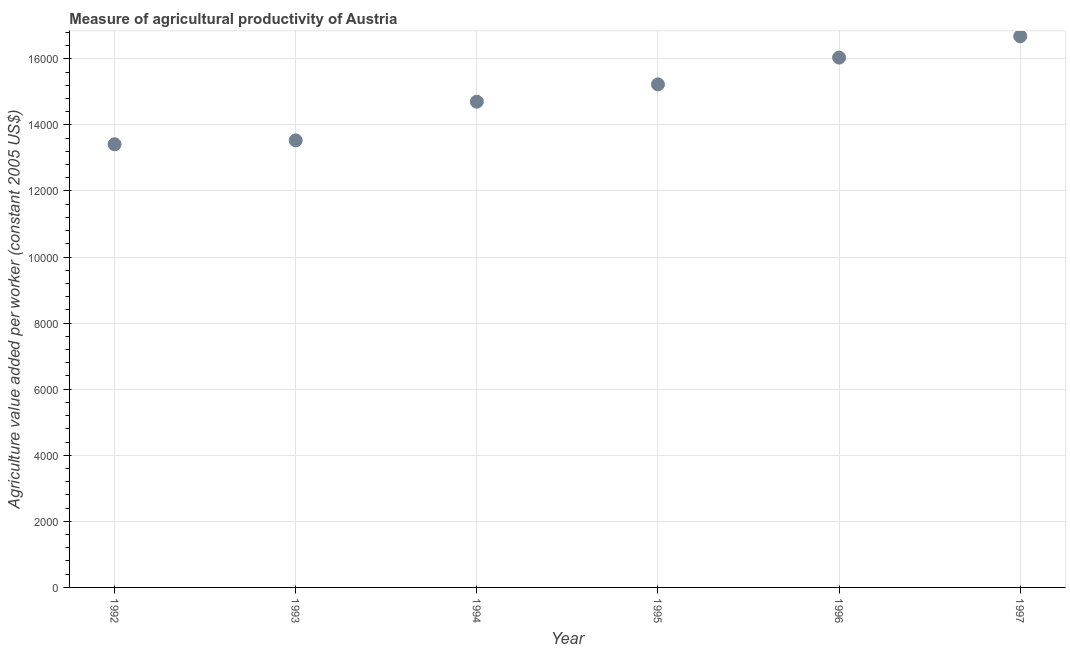What is the agriculture value added per worker in 1993?
Offer a terse response. 1.35e+04. Across all years, what is the maximum agriculture value added per worker?
Offer a terse response. 1.67e+04. Across all years, what is the minimum agriculture value added per worker?
Offer a very short reply. 1.34e+04. In which year was the agriculture value added per worker maximum?
Your answer should be compact. 1997. What is the sum of the agriculture value added per worker?
Your response must be concise. 8.96e+04. What is the difference between the agriculture value added per worker in 1992 and 1994?
Offer a very short reply. -1288.85. What is the average agriculture value added per worker per year?
Make the answer very short. 1.49e+04. What is the median agriculture value added per worker?
Give a very brief answer. 1.50e+04. Do a majority of the years between 1993 and 1994 (inclusive) have agriculture value added per worker greater than 11600 US$?
Your answer should be very brief. Yes. What is the ratio of the agriculture value added per worker in 1992 to that in 1997?
Provide a short and direct response. 0.8. Is the difference between the agriculture value added per worker in 1994 and 1996 greater than the difference between any two years?
Keep it short and to the point. No. What is the difference between the highest and the second highest agriculture value added per worker?
Offer a terse response. 646.43. What is the difference between the highest and the lowest agriculture value added per worker?
Offer a terse response. 3269.82. How many dotlines are there?
Keep it short and to the point. 1. Are the values on the major ticks of Y-axis written in scientific E-notation?
Your answer should be very brief. No. Does the graph contain any zero values?
Keep it short and to the point. No. Does the graph contain grids?
Ensure brevity in your answer.  Yes. What is the title of the graph?
Offer a terse response. Measure of agricultural productivity of Austria. What is the label or title of the Y-axis?
Your response must be concise. Agriculture value added per worker (constant 2005 US$). What is the Agriculture value added per worker (constant 2005 US$) in 1992?
Ensure brevity in your answer.  1.34e+04. What is the Agriculture value added per worker (constant 2005 US$) in 1993?
Give a very brief answer. 1.35e+04. What is the Agriculture value added per worker (constant 2005 US$) in 1994?
Your response must be concise. 1.47e+04. What is the Agriculture value added per worker (constant 2005 US$) in 1995?
Your response must be concise. 1.52e+04. What is the Agriculture value added per worker (constant 2005 US$) in 1996?
Your answer should be compact. 1.60e+04. What is the Agriculture value added per worker (constant 2005 US$) in 1997?
Your answer should be compact. 1.67e+04. What is the difference between the Agriculture value added per worker (constant 2005 US$) in 1992 and 1993?
Give a very brief answer. -117.39. What is the difference between the Agriculture value added per worker (constant 2005 US$) in 1992 and 1994?
Your response must be concise. -1288.85. What is the difference between the Agriculture value added per worker (constant 2005 US$) in 1992 and 1995?
Your answer should be very brief. -1812.25. What is the difference between the Agriculture value added per worker (constant 2005 US$) in 1992 and 1996?
Make the answer very short. -2623.39. What is the difference between the Agriculture value added per worker (constant 2005 US$) in 1992 and 1997?
Your answer should be very brief. -3269.82. What is the difference between the Agriculture value added per worker (constant 2005 US$) in 1993 and 1994?
Give a very brief answer. -1171.46. What is the difference between the Agriculture value added per worker (constant 2005 US$) in 1993 and 1995?
Provide a short and direct response. -1694.85. What is the difference between the Agriculture value added per worker (constant 2005 US$) in 1993 and 1996?
Your answer should be very brief. -2506. What is the difference between the Agriculture value added per worker (constant 2005 US$) in 1993 and 1997?
Your answer should be compact. -3152.43. What is the difference between the Agriculture value added per worker (constant 2005 US$) in 1994 and 1995?
Keep it short and to the point. -523.4. What is the difference between the Agriculture value added per worker (constant 2005 US$) in 1994 and 1996?
Keep it short and to the point. -1334.54. What is the difference between the Agriculture value added per worker (constant 2005 US$) in 1994 and 1997?
Keep it short and to the point. -1980.97. What is the difference between the Agriculture value added per worker (constant 2005 US$) in 1995 and 1996?
Ensure brevity in your answer.  -811.14. What is the difference between the Agriculture value added per worker (constant 2005 US$) in 1995 and 1997?
Provide a short and direct response. -1457.58. What is the difference between the Agriculture value added per worker (constant 2005 US$) in 1996 and 1997?
Provide a succinct answer. -646.43. What is the ratio of the Agriculture value added per worker (constant 2005 US$) in 1992 to that in 1993?
Your response must be concise. 0.99. What is the ratio of the Agriculture value added per worker (constant 2005 US$) in 1992 to that in 1994?
Your answer should be compact. 0.91. What is the ratio of the Agriculture value added per worker (constant 2005 US$) in 1992 to that in 1995?
Make the answer very short. 0.88. What is the ratio of the Agriculture value added per worker (constant 2005 US$) in 1992 to that in 1996?
Your response must be concise. 0.84. What is the ratio of the Agriculture value added per worker (constant 2005 US$) in 1992 to that in 1997?
Make the answer very short. 0.8. What is the ratio of the Agriculture value added per worker (constant 2005 US$) in 1993 to that in 1995?
Provide a short and direct response. 0.89. What is the ratio of the Agriculture value added per worker (constant 2005 US$) in 1993 to that in 1996?
Make the answer very short. 0.84. What is the ratio of the Agriculture value added per worker (constant 2005 US$) in 1993 to that in 1997?
Ensure brevity in your answer.  0.81. What is the ratio of the Agriculture value added per worker (constant 2005 US$) in 1994 to that in 1995?
Provide a short and direct response. 0.97. What is the ratio of the Agriculture value added per worker (constant 2005 US$) in 1994 to that in 1996?
Give a very brief answer. 0.92. What is the ratio of the Agriculture value added per worker (constant 2005 US$) in 1994 to that in 1997?
Keep it short and to the point. 0.88. What is the ratio of the Agriculture value added per worker (constant 2005 US$) in 1995 to that in 1996?
Provide a short and direct response. 0.95. What is the ratio of the Agriculture value added per worker (constant 2005 US$) in 1995 to that in 1997?
Your answer should be compact. 0.91. 